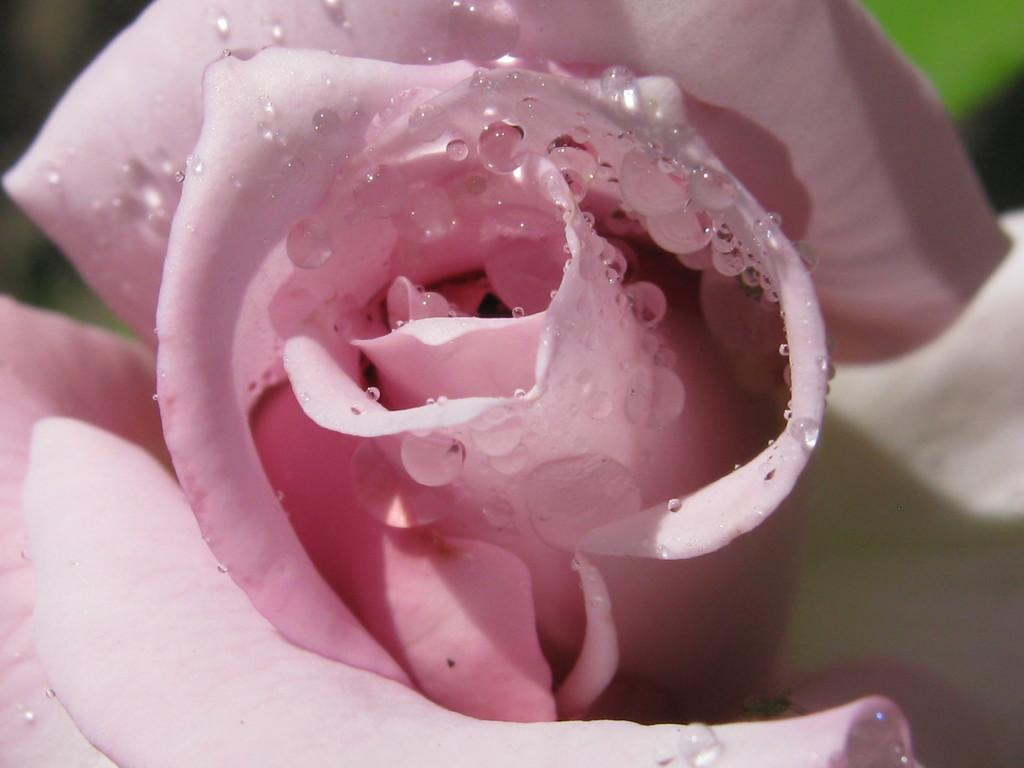What is the main subject of the image? There is a flower in the image. What color is the flower? The flower is pink. Can you describe the background of the image? The background of the image is blurred. How many units does the mother have in the image? There is no mention of units, mother, or sisters in the image, so this question cannot be answered. 